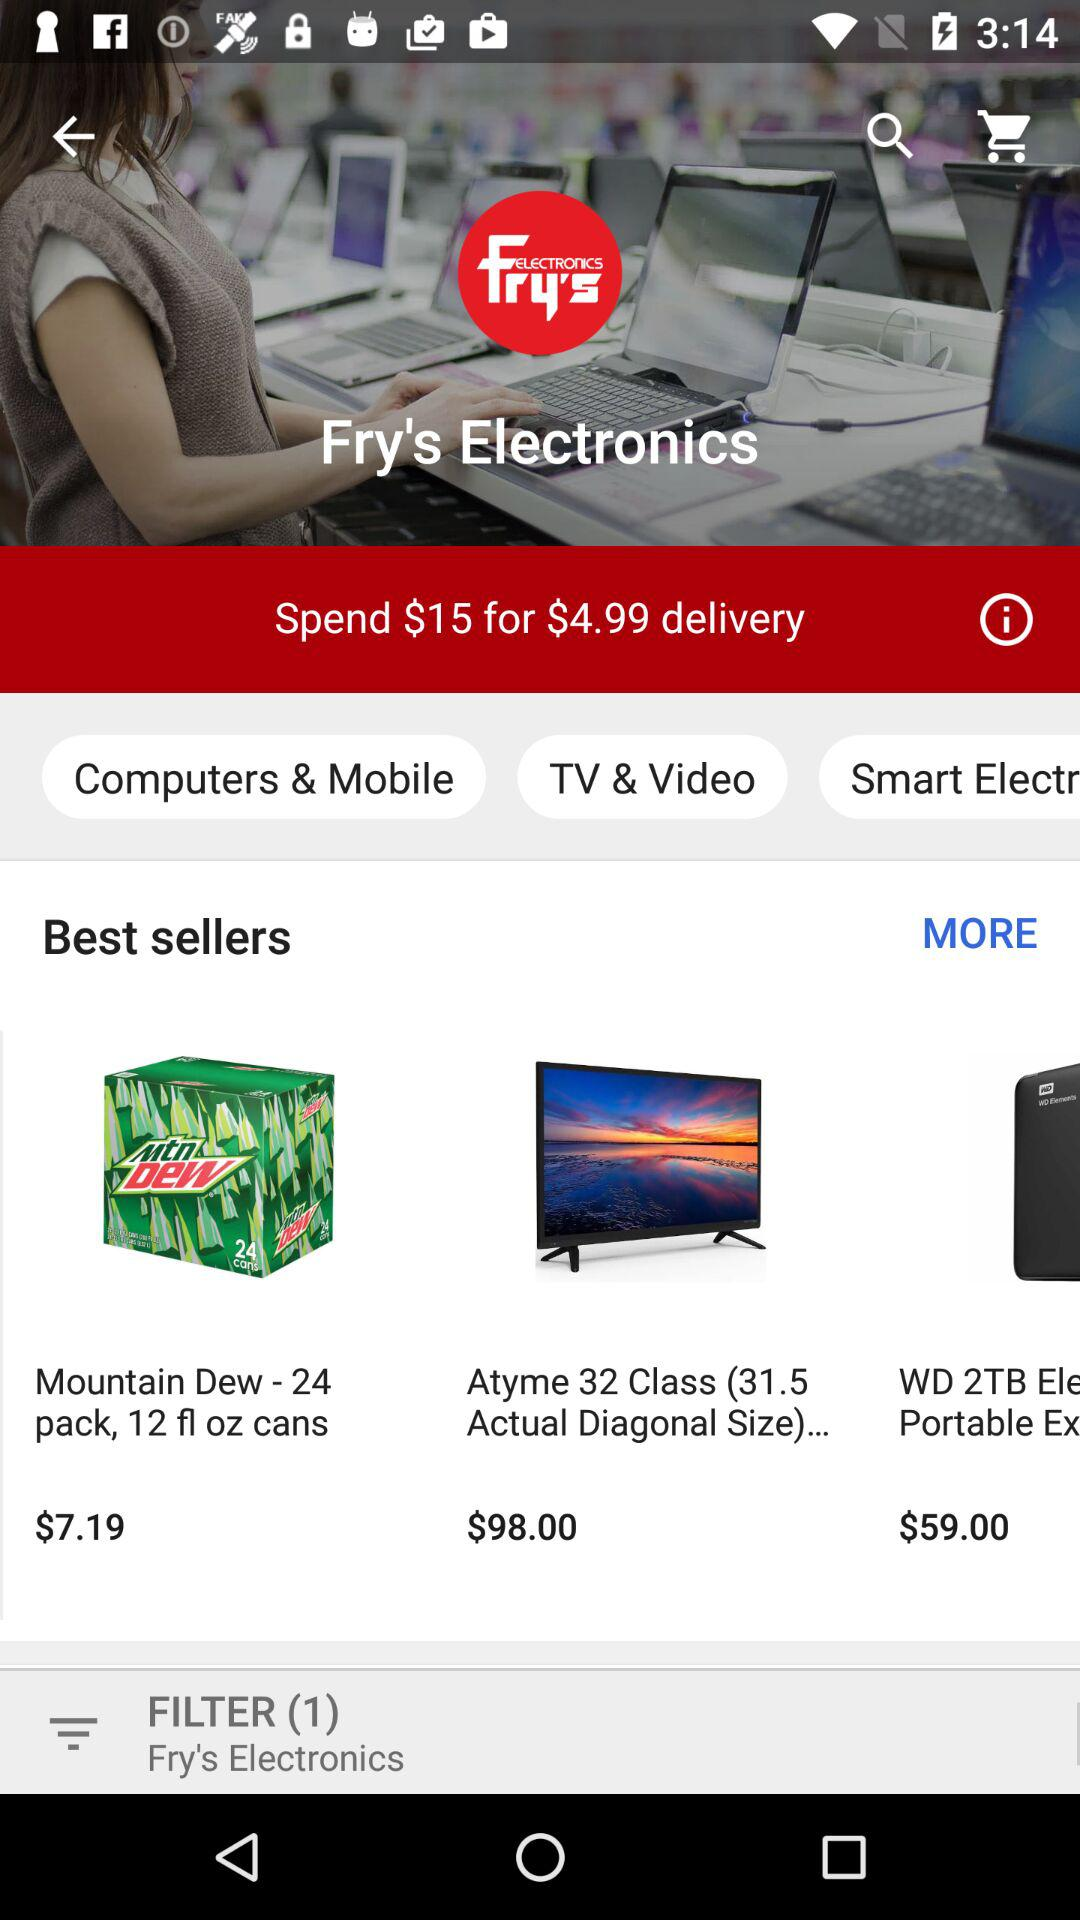How much money do I have to spend for $4.99 delivery? You have to spend $15 for $4.99 delivery. 